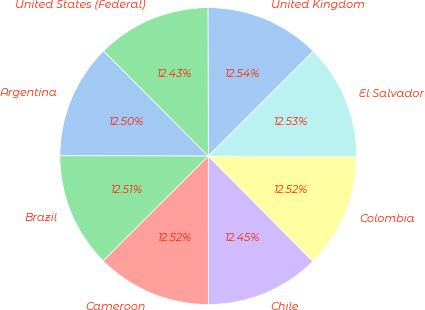<chart> <loc_0><loc_0><loc_500><loc_500><pie_chart><fcel>Argentina<fcel>Brazil<fcel>Cameroon<fcel>Chile<fcel>Colombia<fcel>El Salvador<fcel>United Kingdom<fcel>United States (Federal)<nl><fcel>12.5%<fcel>12.51%<fcel>12.52%<fcel>12.45%<fcel>12.52%<fcel>12.53%<fcel>12.54%<fcel>12.43%<nl></chart> 